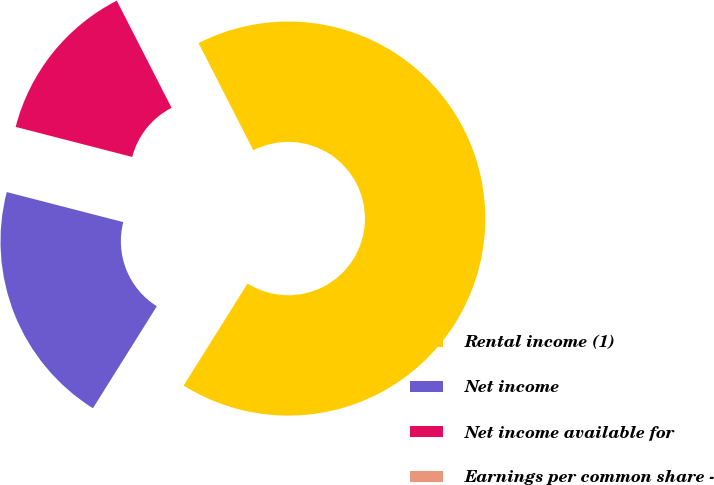Convert chart. <chart><loc_0><loc_0><loc_500><loc_500><pie_chart><fcel>Rental income (1)<fcel>Net income<fcel>Net income available for<fcel>Earnings per common share -<nl><fcel>66.43%<fcel>20.11%<fcel>13.46%<fcel>0.0%<nl></chart> 